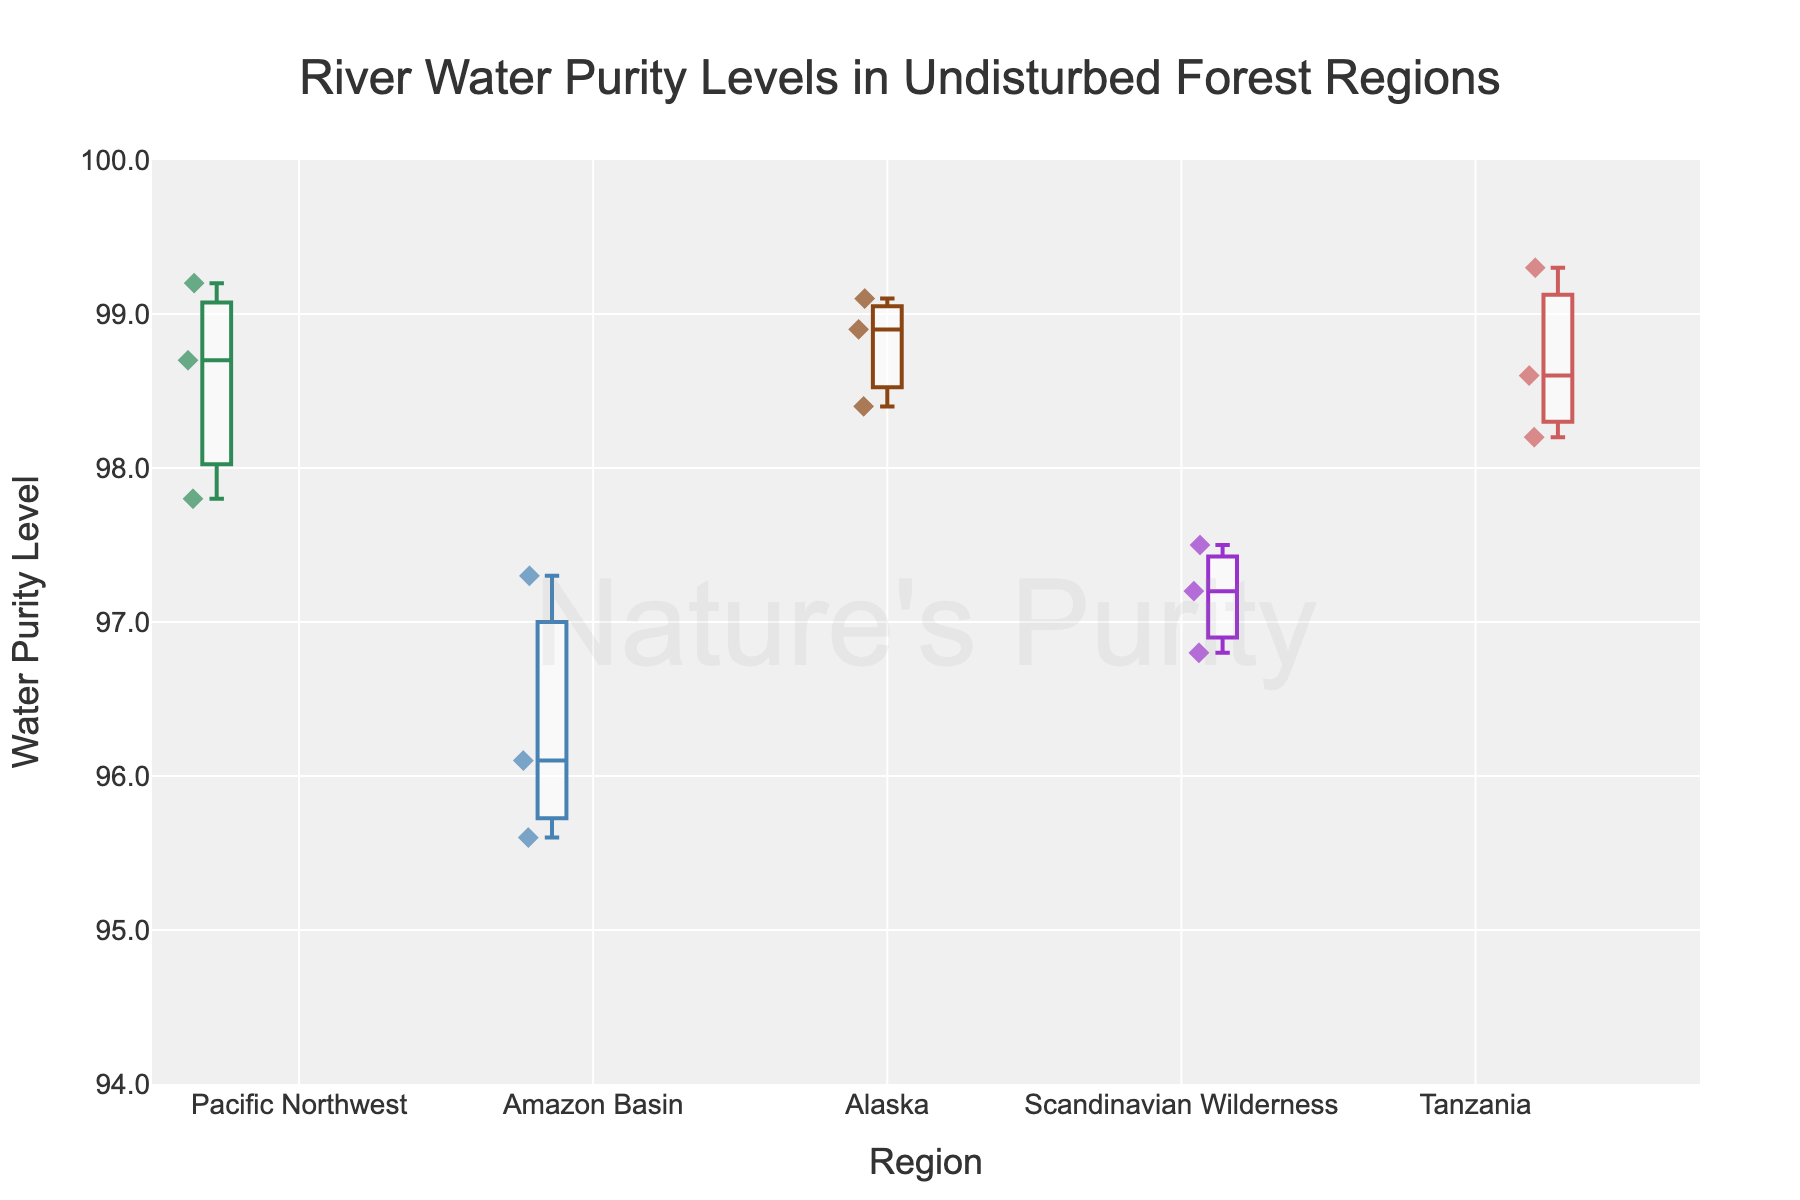What is the title of the figure? The title is located at the top of the figure and generally provides a summary of what the plot represents. In this case, the title is "River Water Purity Levels in Undisturbed Forest Regions."
Answer: River Water Purity Levels in Undisturbed Forest Regions What is the y-axis labeled as? The y-axis label is found on the vertical axis and indicates what is being measured. In this plot, it is labeled as "Water Purity Level."
Answer: Water Purity Level Which region has the highest median water purity level? The median level in a box plot is represented by the line inside the box. By comparing the medians, we can see that Tanzania has the highest median water purity level.
Answer: Tanzania What is the range of water purity levels in the Amazon Basin? The range in a box plot is the distance between the minimum and maximum values within that box. The Amazon Basin's water purity levels range approximately from 95.6 to 97.3.
Answer: 95.6 to 97.3 Which region appears to have the most variability in water purity levels? Variability can be assessed by looking at the interquartile range (IQR) which is the length of the box. The Amazon Basin seems to have the largest IQR, indicating the most variability.
Answer: Amazon Basin How do the water purity levels in the Pacific Northwest compare to those in Alaska? To compare, we look at the medians, spread (IQR), and range of the two regions. The Pacific Northwest has slightly lower median purity levels and slightly higher variability compared to Alaska. Both regions have high purity, but Alaska's levels are more consistent.
Answer: Alaska has slightly better purity levels Which region has the highest maximum water purity level, and what is that level? The maximum level is the uppermost point or the highest point reached by the whisker in a box plot. The highest maximum purity level is in Tanzania, with a value of 99.3.
Answer: Tanzania, 99.3 What is the median water purity level of the Scandinavian Wilderness region? The median is the middle line in the box of the box plot. For the Scandinavian Wilderness, it is approximately 97.2.
Answer: 97.2 Between which two regions is there the smallest difference in median water purity levels? By comparing the medians of all regions, the smallest difference is between the Pacific Northwest and Alaska. Both regions have medians close to each other.
Answer: Pacific Northwest and Alaska How does the spread of data points in the Scandinavian Wilderness compare to that in the Pacific Northwest? The spread or variability within a region can be seen by the size of the box and the length of the whiskers. The Scandinavian Wilderness has a smaller spread compared to the Pacific Northwest, suggesting more consistent water purity levels.
Answer: Scandinavian Wilderness has less variability 